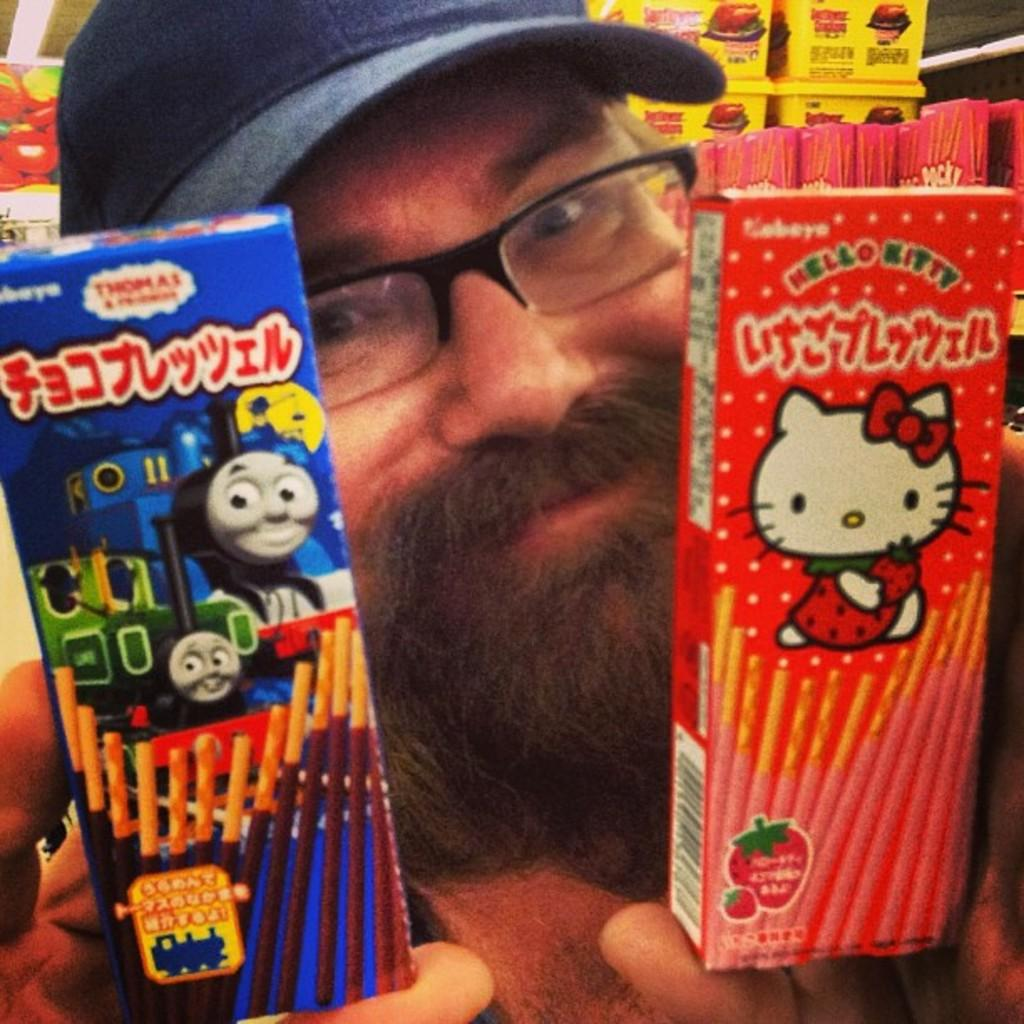What is the main subject in the foreground of the image? There is a person in the foreground of the image. What is the person holding in the image? The person is holding some packets. What can be seen in the background of the image? There are boxes and objects and objects in the background of the image. What type of flag is being waved by the person in the image? There is no flag present in the image; the person is holding packets. How many eyes does the person have in the image? The image does not show the person's eyes, so it is impossible to determine the number of eyes. 